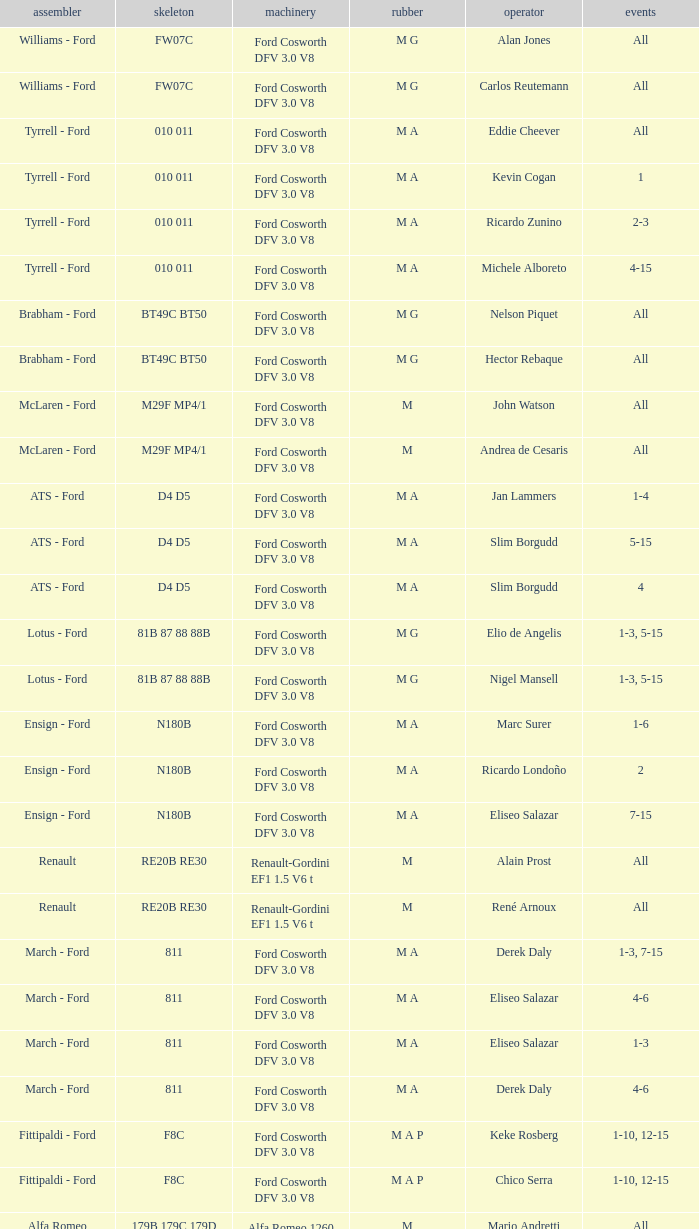Who constructed the car that Derek Warwick raced in with a TG181 chassis? Toleman - Hart. 